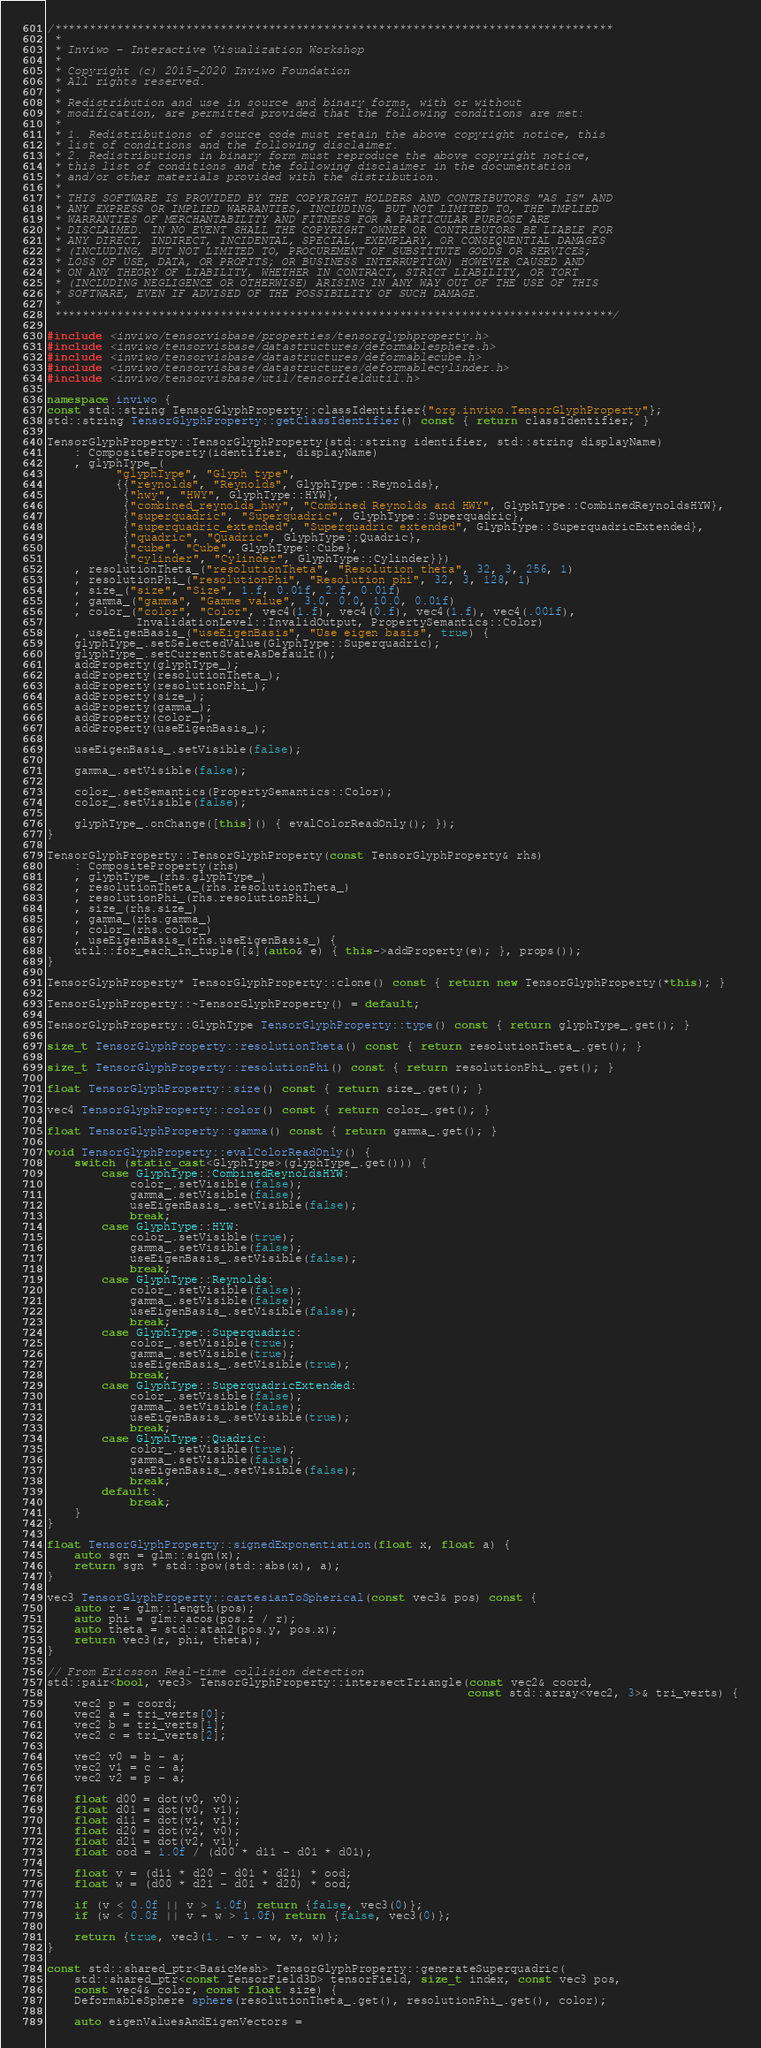Convert code to text. <code><loc_0><loc_0><loc_500><loc_500><_C++_>/*********************************************************************************
 *
 * Inviwo - Interactive Visualization Workshop
 *
 * Copyright (c) 2015-2020 Inviwo Foundation
 * All rights reserved.
 *
 * Redistribution and use in source and binary forms, with or without
 * modification, are permitted provided that the following conditions are met:
 *
 * 1. Redistributions of source code must retain the above copyright notice, this
 * list of conditions and the following disclaimer.
 * 2. Redistributions in binary form must reproduce the above copyright notice,
 * this list of conditions and the following disclaimer in the documentation
 * and/or other materials provided with the distribution.
 *
 * THIS SOFTWARE IS PROVIDED BY THE COPYRIGHT HOLDERS AND CONTRIBUTORS "AS IS" AND
 * ANY EXPRESS OR IMPLIED WARRANTIES, INCLUDING, BUT NOT LIMITED TO, THE IMPLIED
 * WARRANTIES OF MERCHANTABILITY AND FITNESS FOR A PARTICULAR PURPOSE ARE
 * DISCLAIMED. IN NO EVENT SHALL THE COPYRIGHT OWNER OR CONTRIBUTORS BE LIABLE FOR
 * ANY DIRECT, INDIRECT, INCIDENTAL, SPECIAL, EXEMPLARY, OR CONSEQUENTIAL DAMAGES
 * (INCLUDING, BUT NOT LIMITED TO, PROCUREMENT OF SUBSTITUTE GOODS OR SERVICES;
 * LOSS OF USE, DATA, OR PROFITS; OR BUSINESS INTERRUPTION) HOWEVER CAUSED AND
 * ON ANY THEORY OF LIABILITY, WHETHER IN CONTRACT, STRICT LIABILITY, OR TORT
 * (INCLUDING NEGLIGENCE OR OTHERWISE) ARISING IN ANY WAY OUT OF THE USE OF THIS
 * SOFTWARE, EVEN IF ADVISED OF THE POSSIBILITY OF SUCH DAMAGE.
 *
 *********************************************************************************/

#include <inviwo/tensorvisbase/properties/tensorglyphproperty.h>
#include <inviwo/tensorvisbase/datastructures/deformablesphere.h>
#include <inviwo/tensorvisbase/datastructures/deformablecube.h>
#include <inviwo/tensorvisbase/datastructures/deformablecylinder.h>
#include <inviwo/tensorvisbase/util/tensorfieldutil.h>

namespace inviwo {
const std::string TensorGlyphProperty::classIdentifier{"org.inviwo.TensorGlyphProperty"};
std::string TensorGlyphProperty::getClassIdentifier() const { return classIdentifier; }

TensorGlyphProperty::TensorGlyphProperty(std::string identifier, std::string displayName)
    : CompositeProperty(identifier, displayName)
    , glyphType_(
          "glyphType", "Glyph type",
          {{"reynolds", "Reynolds", GlyphType::Reynolds},
           {"hwy", "HWY", GlyphType::HYW},
           {"combined_reynolds_hwy", "Combined Reynolds and HWY", GlyphType::CombinedReynoldsHYW},
           {"superquadric", "Superquadric", GlyphType::Superquadric},
           {"superquadric_extended", "Superquadric extended", GlyphType::SuperquadricExtended},
           {"quadric", "Quadric", GlyphType::Quadric},
           {"cube", "Cube", GlyphType::Cube},
           {"cylinder", "Cylinder", GlyphType::Cylinder}})
    , resolutionTheta_("resolutionTheta", "Resolution theta", 32, 3, 256, 1)
    , resolutionPhi_("resolutionPhi", "Resolution phi", 32, 3, 128, 1)
    , size_("size", "Size", 1.f, 0.01f, 2.f, 0.01f)
    , gamma_("gamma", "Gamme value", 3.0, 0.0, 10.0, 0.01f)
    , color_("color", "Color", vec4(1.f), vec4(0.f), vec4(1.f), vec4(.001f),
             InvalidationLevel::InvalidOutput, PropertySemantics::Color)
    , useEigenBasis_("useEigenBasis", "Use eigen basis", true) {
    glyphType_.setSelectedValue(GlyphType::Superquadric);
    glyphType_.setCurrentStateAsDefault();
    addProperty(glyphType_);
    addProperty(resolutionTheta_);
    addProperty(resolutionPhi_);
    addProperty(size_);
    addProperty(gamma_);
    addProperty(color_);
    addProperty(useEigenBasis_);

    useEigenBasis_.setVisible(false);

    gamma_.setVisible(false);

    color_.setSemantics(PropertySemantics::Color);
    color_.setVisible(false);

    glyphType_.onChange([this]() { evalColorReadOnly(); });
}

TensorGlyphProperty::TensorGlyphProperty(const TensorGlyphProperty& rhs)
    : CompositeProperty(rhs)
    , glyphType_(rhs.glyphType_)
    , resolutionTheta_(rhs.resolutionTheta_)
    , resolutionPhi_(rhs.resolutionPhi_)
    , size_(rhs.size_)
    , gamma_(rhs.gamma_)
    , color_(rhs.color_)
    , useEigenBasis_(rhs.useEigenBasis_) {
    util::for_each_in_tuple([&](auto& e) { this->addProperty(e); }, props());
}

TensorGlyphProperty* TensorGlyphProperty::clone() const { return new TensorGlyphProperty(*this); }

TensorGlyphProperty::~TensorGlyphProperty() = default;

TensorGlyphProperty::GlyphType TensorGlyphProperty::type() const { return glyphType_.get(); }

size_t TensorGlyphProperty::resolutionTheta() const { return resolutionTheta_.get(); }

size_t TensorGlyphProperty::resolutionPhi() const { return resolutionPhi_.get(); }

float TensorGlyphProperty::size() const { return size_.get(); }

vec4 TensorGlyphProperty::color() const { return color_.get(); }

float TensorGlyphProperty::gamma() const { return gamma_.get(); }

void TensorGlyphProperty::evalColorReadOnly() {
    switch (static_cast<GlyphType>(glyphType_.get())) {
        case GlyphType::CombinedReynoldsHYW:
            color_.setVisible(false);
            gamma_.setVisible(false);
            useEigenBasis_.setVisible(false);
            break;
        case GlyphType::HYW:
            color_.setVisible(true);
            gamma_.setVisible(false);
            useEigenBasis_.setVisible(false);
            break;
        case GlyphType::Reynolds:
            color_.setVisible(false);
            gamma_.setVisible(false);
            useEigenBasis_.setVisible(false);
            break;
        case GlyphType::Superquadric:
            color_.setVisible(true);
            gamma_.setVisible(true);
            useEigenBasis_.setVisible(true);
            break;
        case GlyphType::SuperquadricExtended:
            color_.setVisible(false);
            gamma_.setVisible(false);
            useEigenBasis_.setVisible(true);
            break;
        case GlyphType::Quadric:
            color_.setVisible(true);
            gamma_.setVisible(false);
            useEigenBasis_.setVisible(false);
            break;
        default:
            break;
    }
}

float TensorGlyphProperty::signedExponentiation(float x, float a) {
    auto sgn = glm::sign(x);
    return sgn * std::pow(std::abs(x), a);
}

vec3 TensorGlyphProperty::cartesianToSpherical(const vec3& pos) const {
    auto r = glm::length(pos);
    auto phi = glm::acos(pos.z / r);
    auto theta = std::atan2(pos.y, pos.x);
    return vec3(r, phi, theta);
}

// From Ericsson Real-time collision detection
std::pair<bool, vec3> TensorGlyphProperty::intersectTriangle(const vec2& coord,
                                                             const std::array<vec2, 3>& tri_verts) {
    vec2 p = coord;
    vec2 a = tri_verts[0];
    vec2 b = tri_verts[1];
    vec2 c = tri_verts[2];

    vec2 v0 = b - a;
    vec2 v1 = c - a;
    vec2 v2 = p - a;

    float d00 = dot(v0, v0);
    float d01 = dot(v0, v1);
    float d11 = dot(v1, v1);
    float d20 = dot(v2, v0);
    float d21 = dot(v2, v1);
    float ood = 1.0f / (d00 * d11 - d01 * d01);

    float v = (d11 * d20 - d01 * d21) * ood;
    float w = (d00 * d21 - d01 * d20) * ood;

    if (v < 0.0f || v > 1.0f) return {false, vec3(0)};
    if (w < 0.0f || v + w > 1.0f) return {false, vec3(0)};

    return {true, vec3(1. - v - w, v, w)};
}

const std::shared_ptr<BasicMesh> TensorGlyphProperty::generateSuperquadric(
    std::shared_ptr<const TensorField3D> tensorField, size_t index, const vec3 pos,
    const vec4& color, const float size) {
    DeformableSphere sphere(resolutionTheta_.get(), resolutionPhi_.get(), color);

    auto eigenValuesAndEigenVectors =</code> 